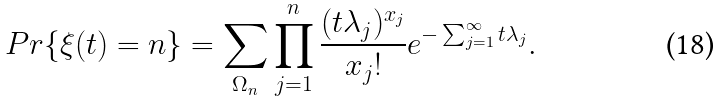Convert formula to latex. <formula><loc_0><loc_0><loc_500><loc_500>P r \{ \xi ( t ) = n \} = \sum _ { \Omega _ { n } } \prod _ { j = 1 } ^ { n } \frac { ( t \lambda _ { j } ) ^ { x _ { j } } } { x _ { j } ! } e ^ { - \sum _ { j = 1 } ^ { \infty } t \lambda _ { j } } .</formula> 